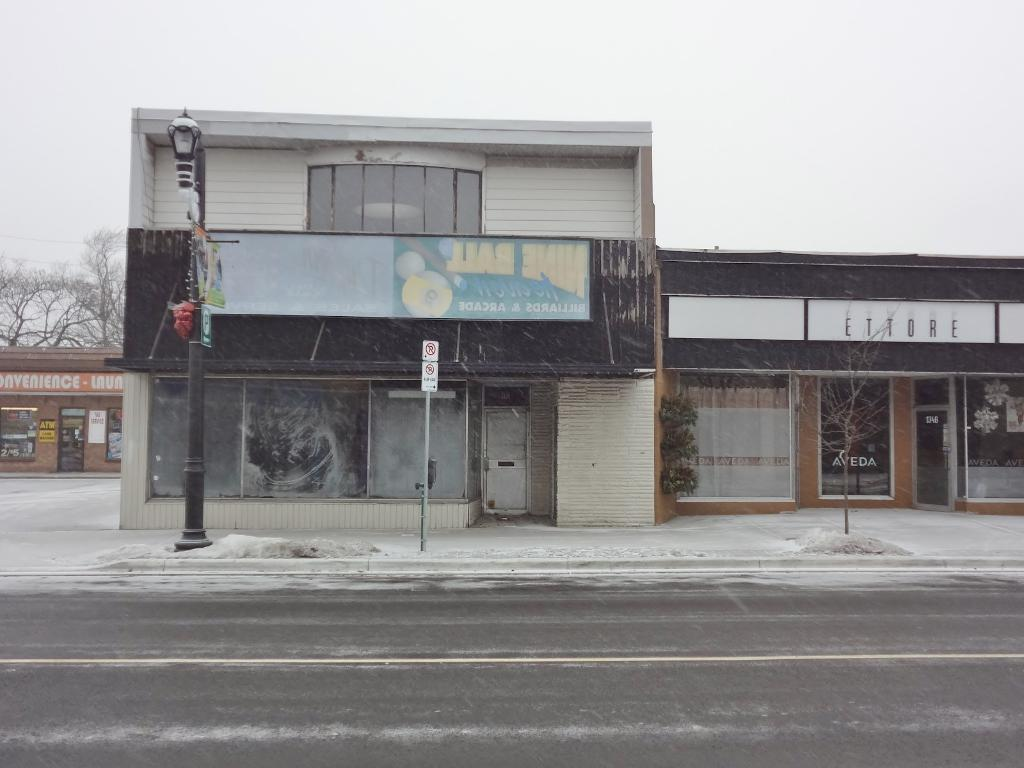What is located at the bottom of the image? There is a road at the bottom of the image. What can be seen in the background of the image? There are buildings, hoardings, glass doors, light poles, a sign board pole, bare trees, and the sky visible in the background of the image. Who is the manager of the giraffe in the image? There is no giraffe present in the image, so there is no manager for a giraffe. 